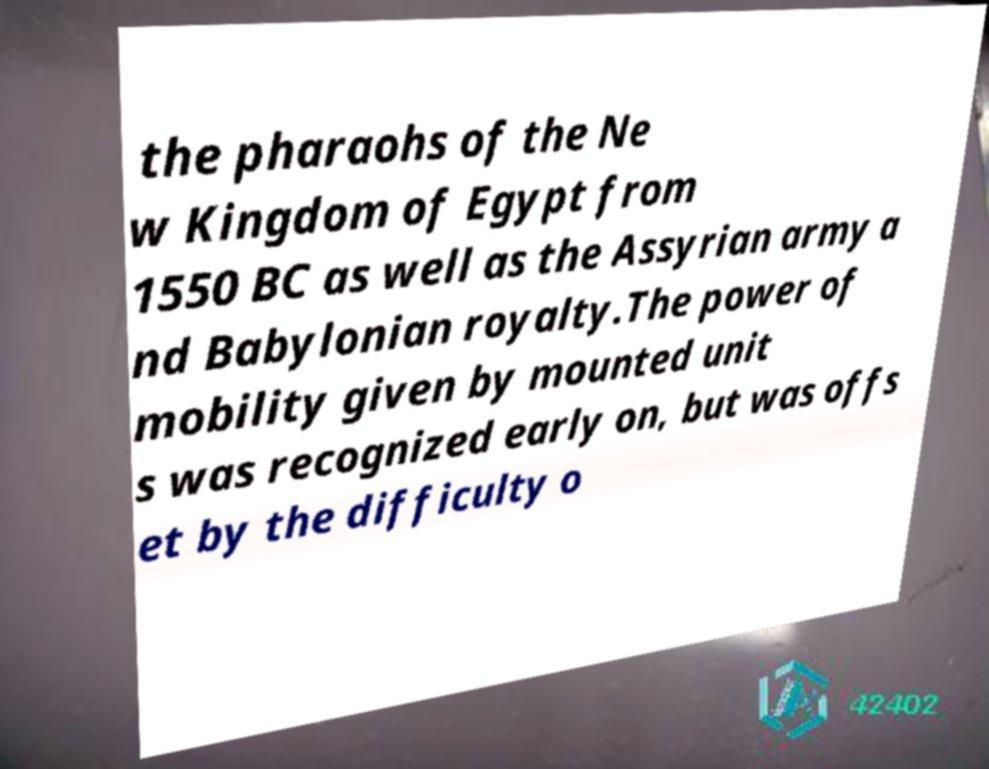Can you read and provide the text displayed in the image?This photo seems to have some interesting text. Can you extract and type it out for me? the pharaohs of the Ne w Kingdom of Egypt from 1550 BC as well as the Assyrian army a nd Babylonian royalty.The power of mobility given by mounted unit s was recognized early on, but was offs et by the difficulty o 